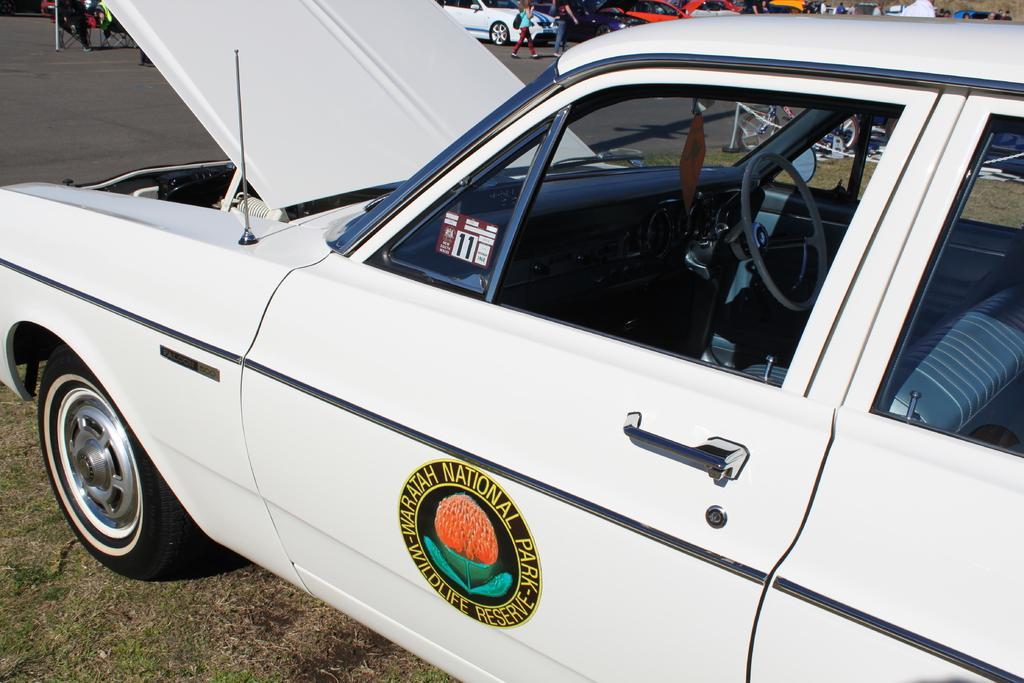In one or two sentences, can you explain what this image depicts? In front of the image there is a car with a logo on it. At the top of the image behind the car there are few people and also there are cars on the road. 